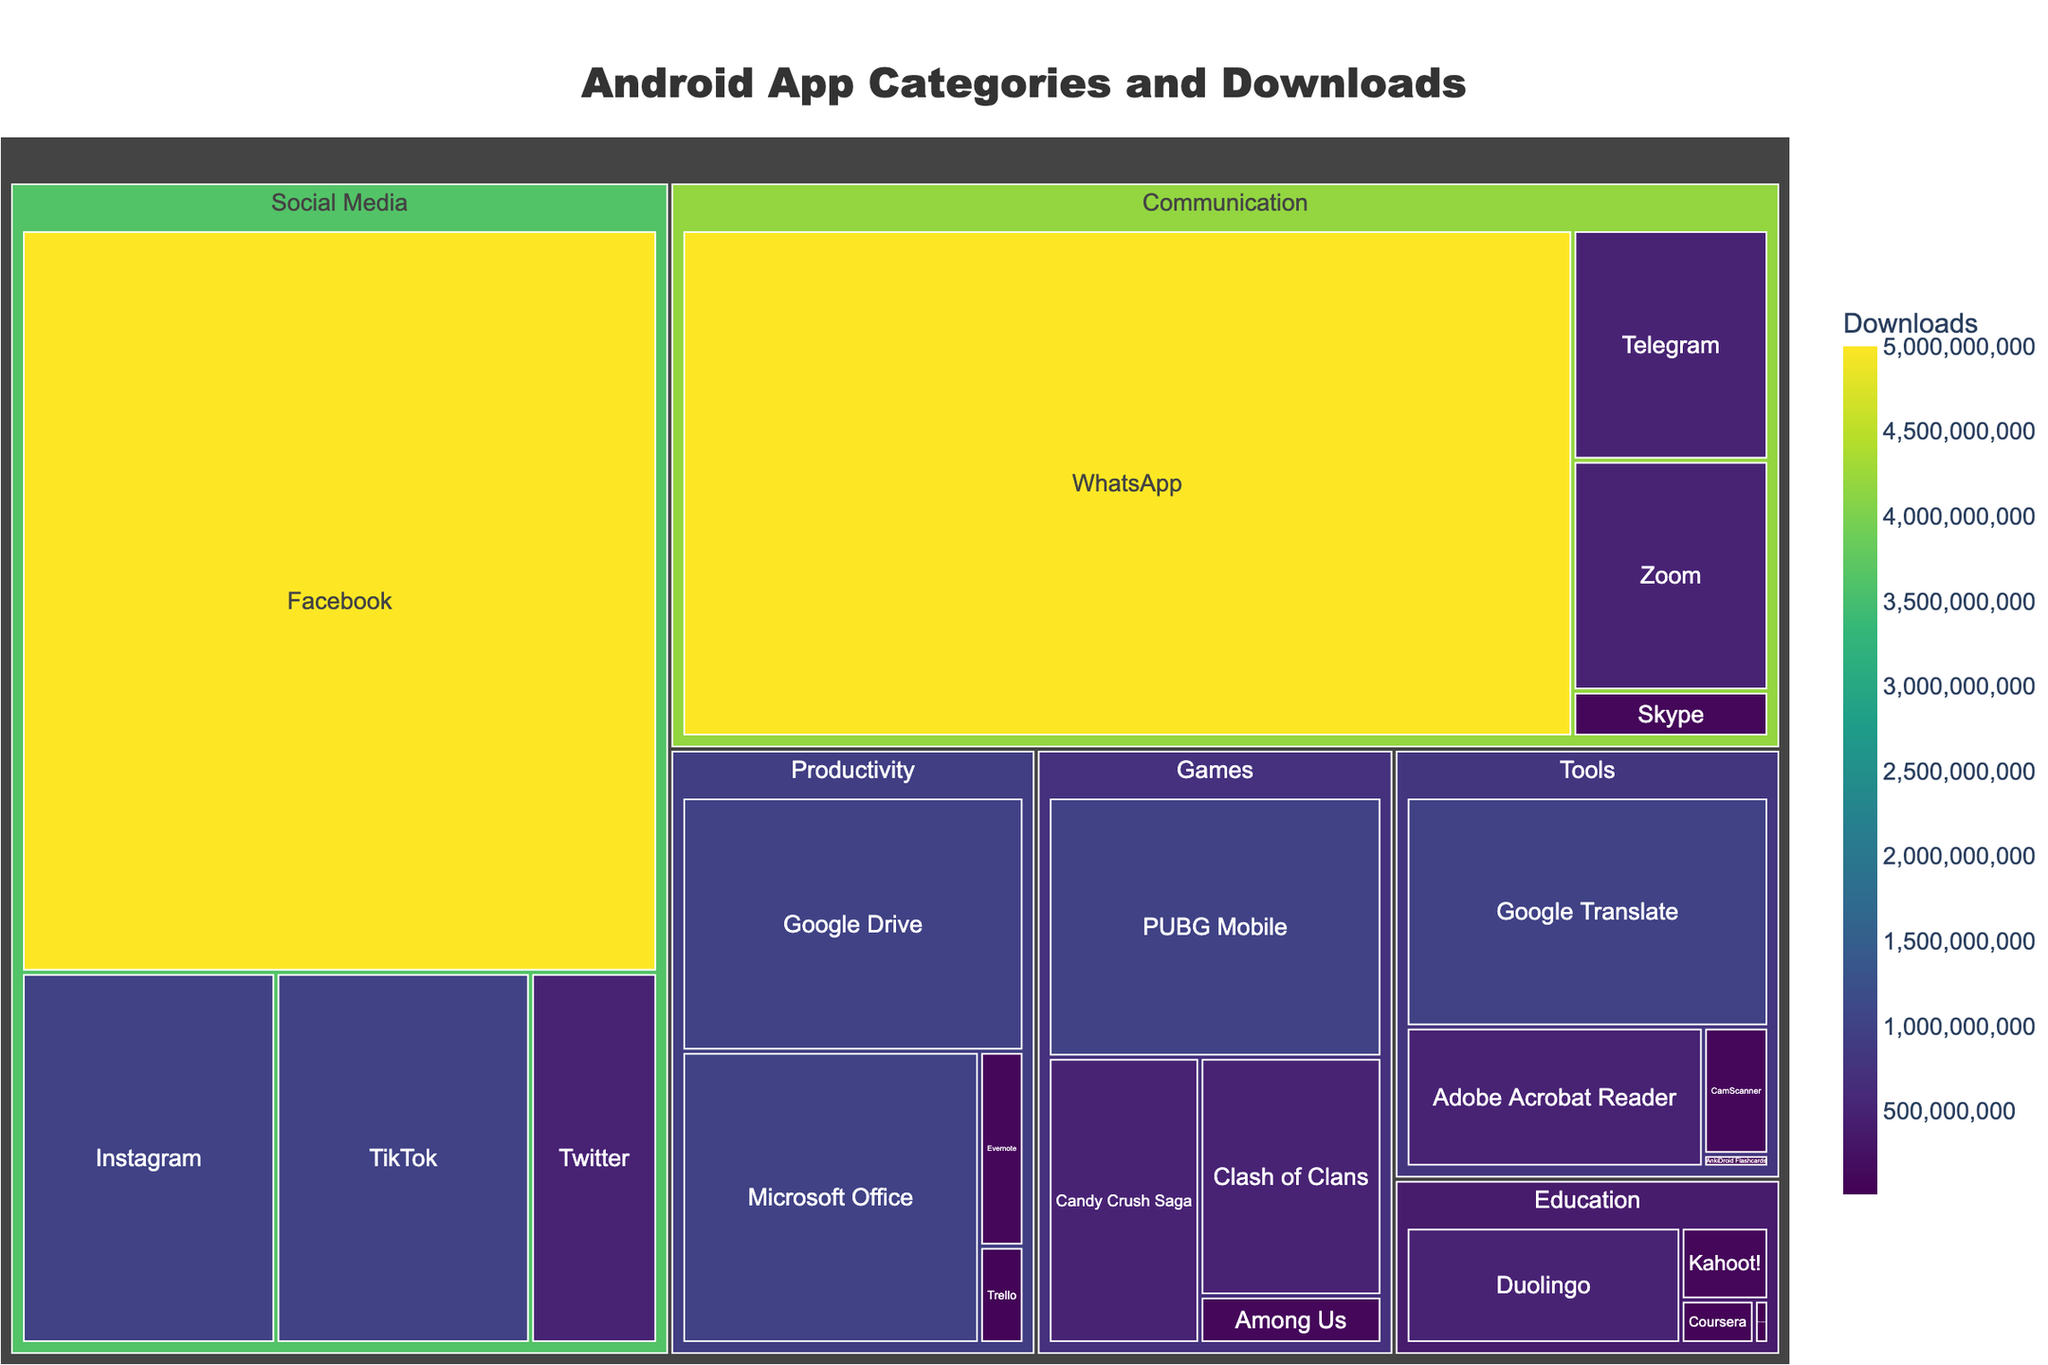Which app has the highest number of downloads in the Social Media category? To determine the app with the highest downloads in the Social Media category, look at the areas representing each app within this category. The largest area corresponds to the app with the highest downloads.
Answer: Facebook Which app has more downloads, WhatsApp or Zoom? Compare the areas representing WhatsApp and Zoom in the Communication category. The larger area corresponds to the app with more downloads.
Answer: WhatsApp How many categories have at least one app with over 1 billion downloads? Identify the categories where at least one app rectangle's size is equivalent to or greater than the 1-billion-download mark based on color intensity and area.
Answer: Four What is the total number of downloads for all apps in the Productivity category? Sum the downloads of all apps in the Productivity category: Microsoft Office (1,000,000,000), Google Drive (1,000,000,000), Evernote (100,000,000), and Trello (50,000,000). Calculate 1,000,000,000 + 1,000,000,000 + 100,000,000 + 50,000,000 = 2,150,000,000.
Answer: 2,150,000,000 Are there more apps with downloads over 500 million in the Social Media or Games category? Count the apps within both the Social Media and Games categories that have downloads exceeding 500 million. Compare the counts.
Answer: Social Media Which category has the least representation in the treemap? Identify the category with the smallest collective area in the treemap. This is typically represented by the least number of or smallest-sized app blocks.
Answer: Education Which app has the lowest downloads in the Education category, and what are its downloads? Within the Education category, find the smallest area block which indicates the app with the lowest downloads.
Answer: Khan Academy with 10,000,000 downloads What is the combined download total for the top two apps in the Tools category? Find the top two apps in the Tools category based on download numbers: Google Translate (1,000,000,000) and Adobe Acrobat Reader (500,000,000). Sum their downloads: 1,000,000,000 + 500,000,000 = 1,500,000,000.
Answer: 1,500,000,000 How many apps have exactly 500 million downloads? Count the areas that correspond to applications with 500 million downloads. Look closely at the labels and hover data to verify the counts.
Answer: Four 